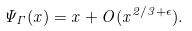<formula> <loc_0><loc_0><loc_500><loc_500>\Psi _ { \Gamma } ( x ) = x + O ( x ^ { 2 / 3 + \epsilon } ) .</formula> 